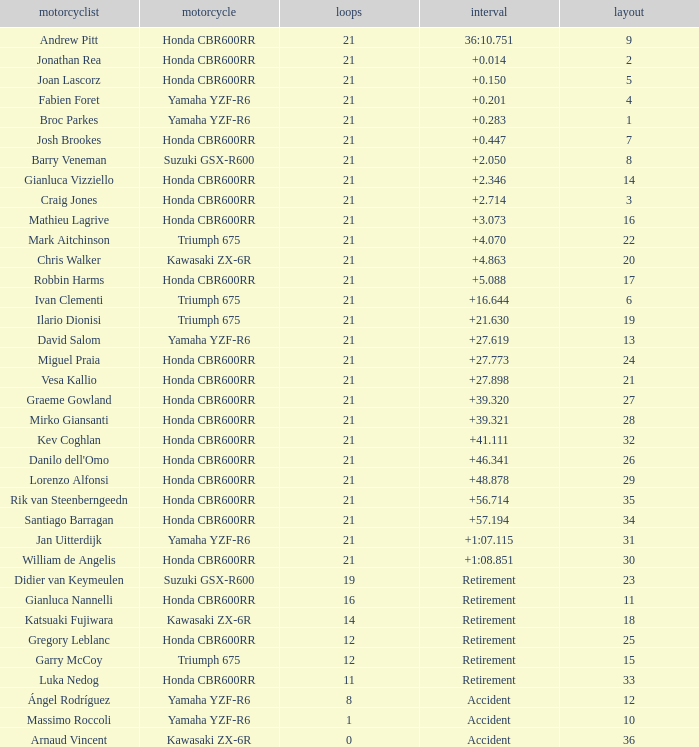What is the most number of laps run by Ilario Dionisi? 21.0. 